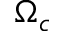<formula> <loc_0><loc_0><loc_500><loc_500>\Omega _ { c }</formula> 